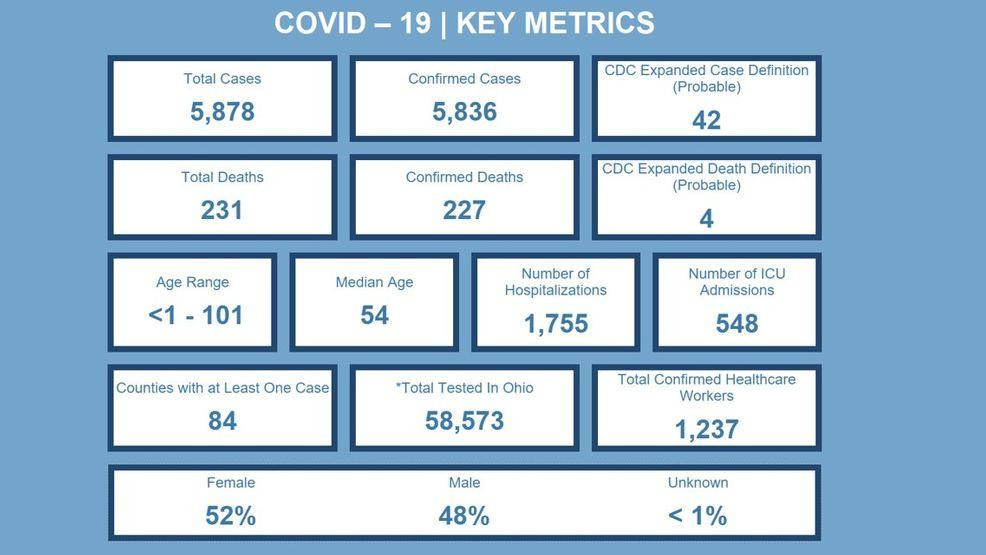Outline some significant characteristics in this image. As of February 18th, 2023, the total number of COVID-19 cases worldwide is 5,878. According to recent statistics, 48% of males are positive for COVID-19. A total of 58,573 people have been tested for COVID-19 in Ohio as of March 12, 2023. As of March 2023, the total number of COVID-19 deaths has reached 231 and continues to rise. According to recent data, it has been found that 52% of females are positive for COVID-19. 